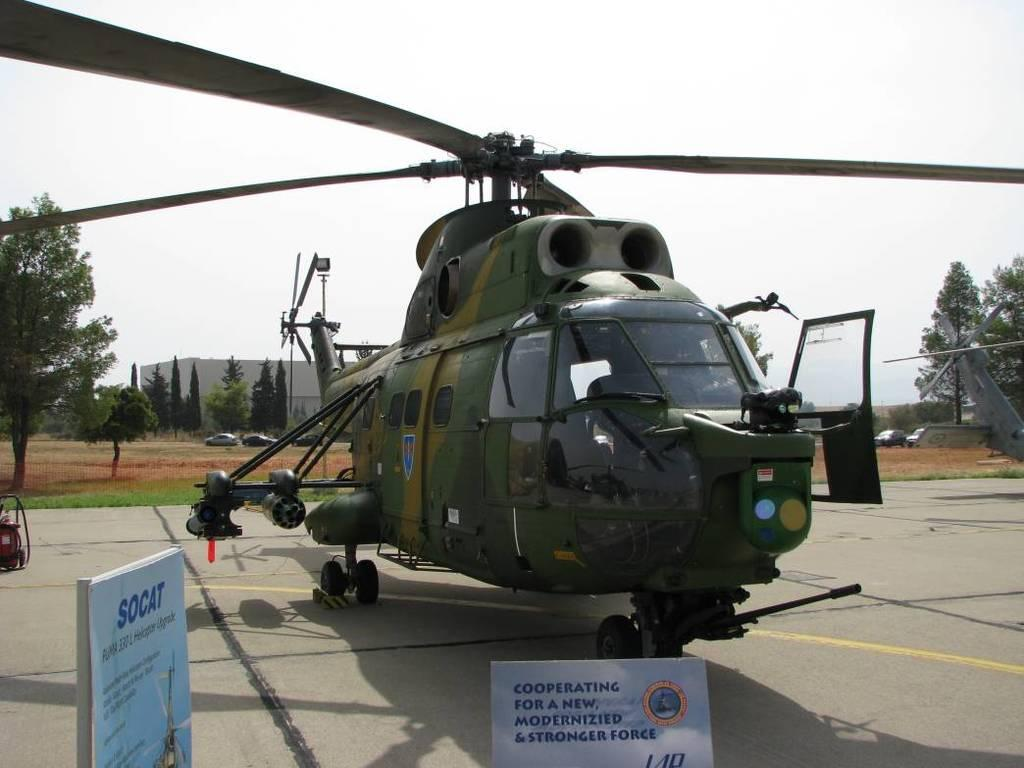<image>
Provide a brief description of the given image. A helicopter is parked on the ground with a sign in front of it that says "cooperating for a new modernized and strong force". 